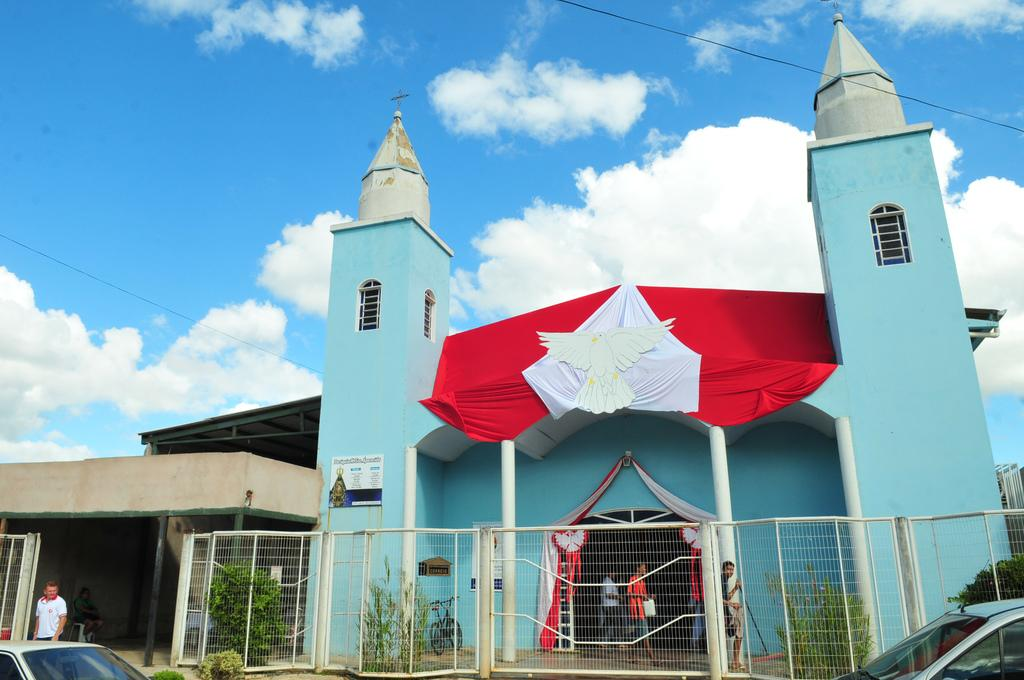What type of structure can be seen in the image? There is a building in the image. What is located near the building? There is a fence in the image. What other objects can be seen in the image? There are poles, windows, plants, a bicycle, vehicles, sheds, and people in the image. What is visible in the background of the image? The sky is visible in the background of the image, with clouds present. Is there a farmer reading a book in the image? There is no farmer or book present in the image. 